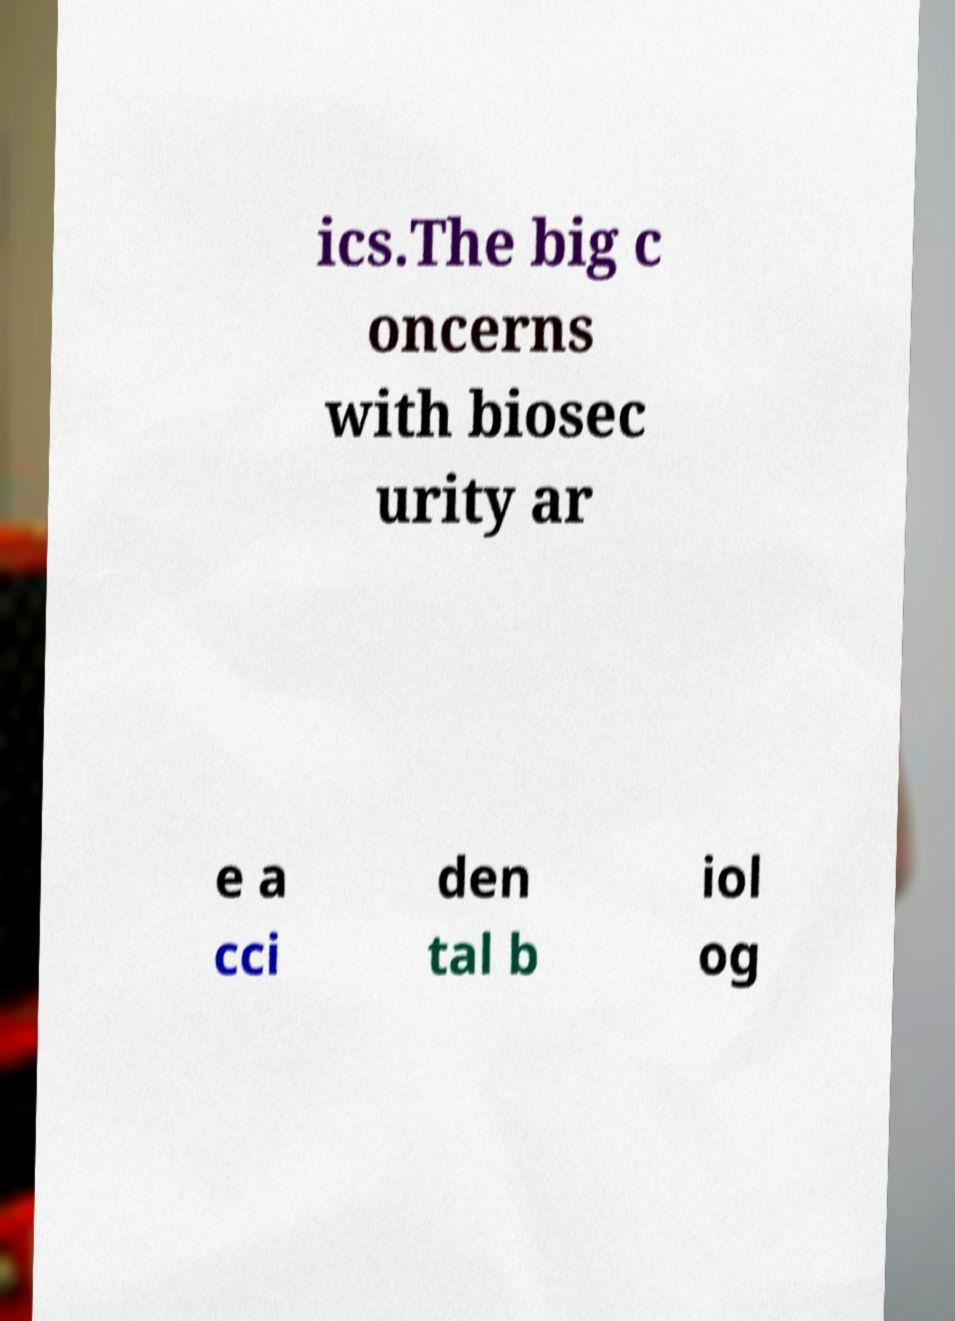Please identify and transcribe the text found in this image. ics.The big c oncerns with biosec urity ar e a cci den tal b iol og 